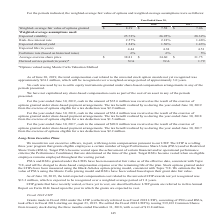According to Opentext Corporation's financial document, How was the derived service period calculated? using Monte Carlo Valuation Method. The document states: "*Options valued using Monte Carlo Valuation Method..." Also, How much was the tax benefit realised by the company during the year ended June 30, 2019? According to the financial document, $1.5 million. The relevant text states: "ercise of options eligible for a tax deduction was $1.5 million...." Also, What does the table show? weighted-average fair value of options and weighted-average assumptions. The document states: "For the periods indicated, the weighted-average fair value of options and weighted-average assumptions were as follows:..." Additionally, What are the Fiscal years, sorted in ascending order of Risk–free interest rate? The document contains multiple relevant values: 2017, 2018, 2019. From the document: "2019 2018 2017 Weighted–average fair value of options granted $ 8.39 $ 7.58 $ 7.06 Weighted-average assumptions us 2019 2018 2017 Weighted–average fai..." Also, can you calculate: What is the average annual expected dividend yield? To answer this question, I need to perform calculations using the financial data. The calculation is: (1.54+1.50+1.43)/3, which equals 1.49 (percentage). This is based on the information: "st rate 2.57% 2.18% 1.46% Expected dividend yield 1.54% 1.50% 1.43% Expected life (in years) 4.44 4.38 4.51 Forfeiture rate (based on historical rates) 6% % 2.18% 1.46% Expected dividend yield 1.54% 1..." The key data points involved are: 1.43, 1.50, 1.54. Also, can you calculate: What is the total tax benefit for fiscal years 2017-2019? Based on the calculation: 2.9+1.5+2.2, the result is 6.6 (in millions). This is based on the information: "cise of options eligible for a tax deduction was $2.9 million. est rate 2.57% 2.18% 1.46% Expected dividend yield 1.54% 1.50% 1.43% Expected life (in years) 4.44 4.38 4.51 Forfeiture rate (based on hi..." The key data points involved are: 1.5, 2.2, 2.9. 